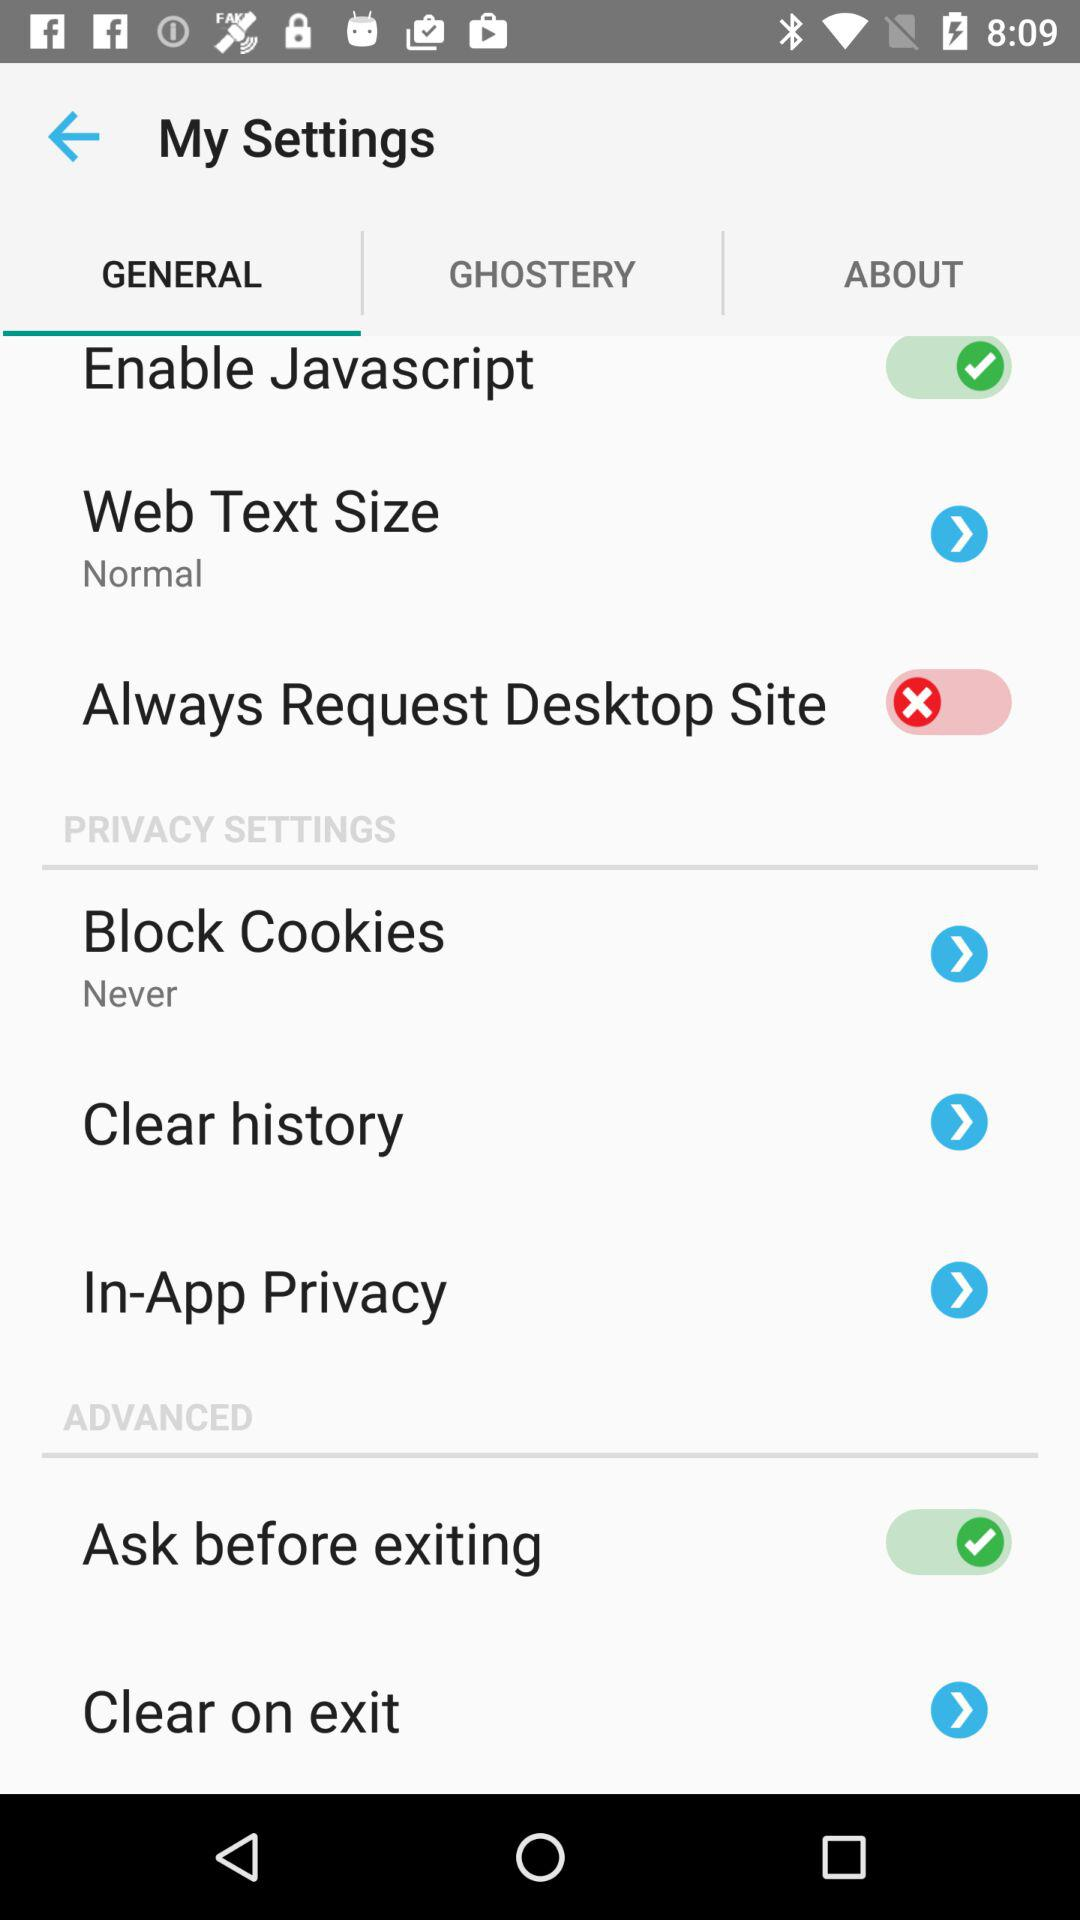Which tab is selected? The selected tab is "GENERAL". 